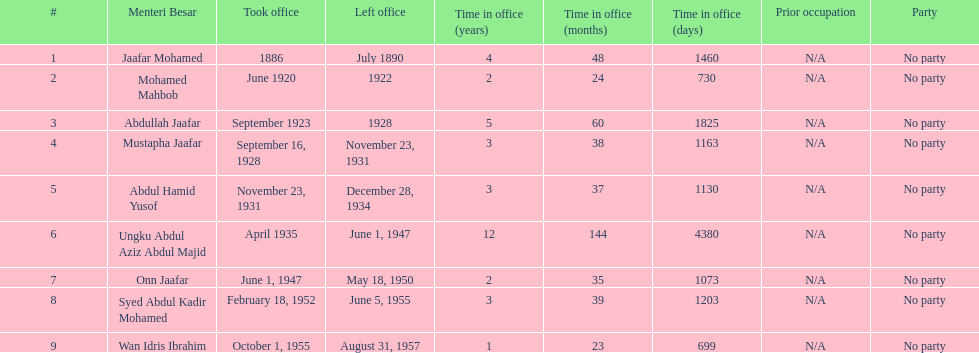Who was the first to take office? Jaafar Mohamed. 